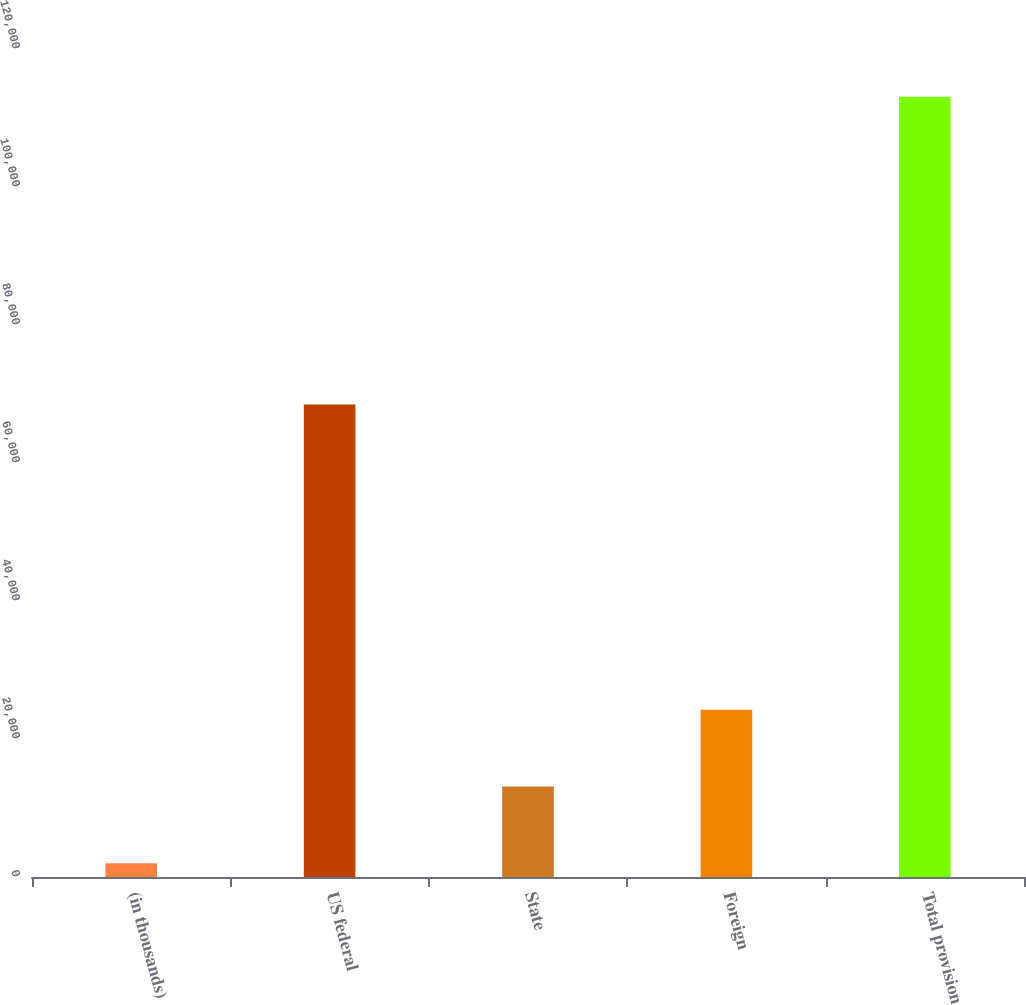Convert chart. <chart><loc_0><loc_0><loc_500><loc_500><bar_chart><fcel>(in thousands)<fcel>US federal<fcel>State<fcel>Foreign<fcel>Total provision<nl><fcel>2008<fcel>68469<fcel>13115<fcel>24222<fcel>113078<nl></chart> 